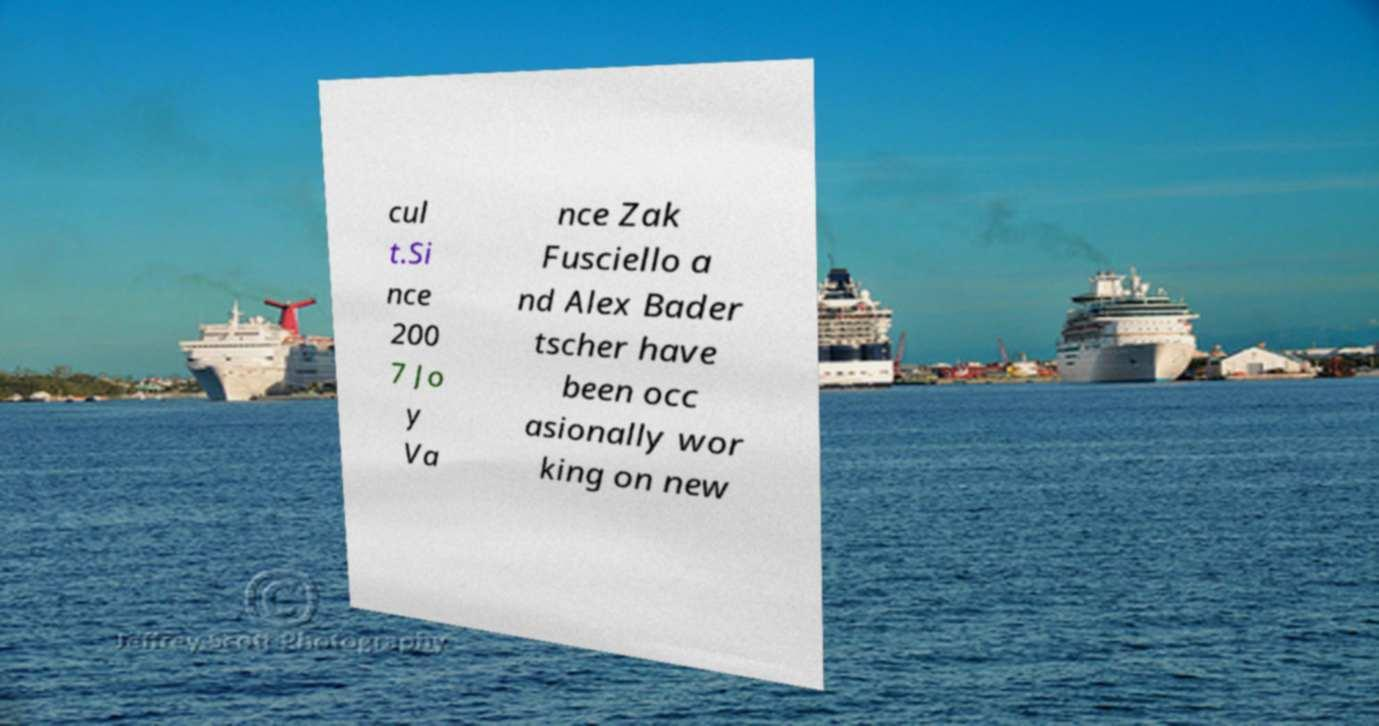Please identify and transcribe the text found in this image. cul t.Si nce 200 7 Jo y Va nce Zak Fusciello a nd Alex Bader tscher have been occ asionally wor king on new 